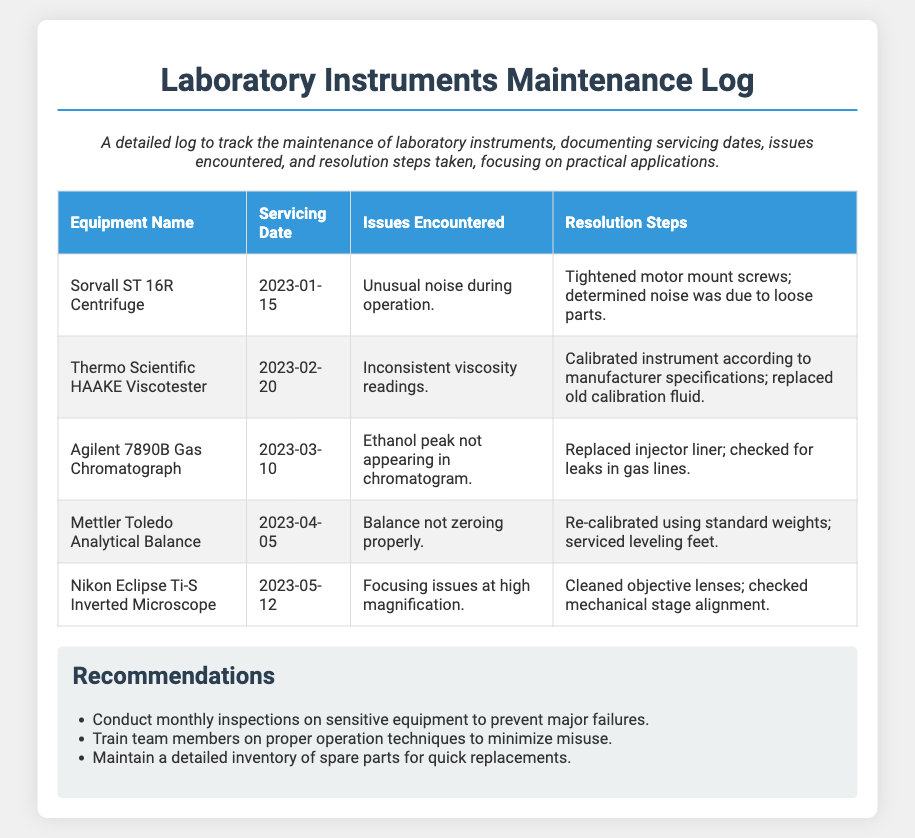What is the name of the first equipment serviced? The first equipment listed in the table is the Sorvall ST 16R Centrifuge, which is mentioned at the top of the log.
Answer: Sorvall ST 16R Centrifuge When was the Thermo Scientific HAAKE Viscotester serviced? The servicing date for the Thermo Scientific HAAKE Viscotester is given in the second row of the table, which states 2023-02-20.
Answer: 2023-02-20 What issue was encountered with the Agilent 7890B Gas Chromatograph? The issue recorded for the Agilent 7890B Gas Chromatograph is noted in the third row, where it states that the ethanol peak was not appearing in the chromatogram.
Answer: Ethanol peak not appearing in chromatogram What resolution steps were taken for the Mettler Toledo Analytical Balance? The resolution steps taken for the Mettler Toledo Analytical Balance include re-calibrating using standard weights and servicing leveling feet, as stated in the fourth entry.
Answer: Re-calibrated using standard weights; serviced leveling feet How many equipment maintenance entries are listed in the document? The document contains a total of five entries for equipment maintenance, as each row in the table represents a separate entry.
Answer: 5 Which equipment was serviced on 2023-05-12? The equipment serviced on this date is specifically mentioned in the fifth row of the table as the Nikon Eclipse Ti-S Inverted Microscope.
Answer: Nikon Eclipse Ti-S Inverted Microscope What is one recommendation provided in the log? The recommendations section lists several items, and one example is to conduct monthly inspections on sensitive equipment to prevent major failures.
Answer: Conduct monthly inspections on sensitive equipment to prevent major failures 